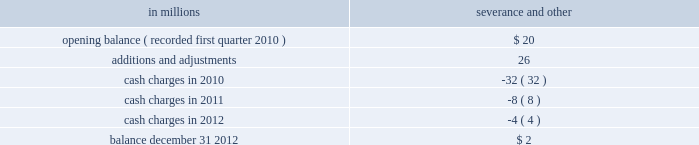The table presents a rollforward of the severance and other costs for approximately 1650 employees included in the 2010 restructuring charg- in millions severance and other .
As of december 31 , 2012 , 1638 employees had left the company under these programs .
Cellulosic bio-fuel tax credit in a memorandum dated june 28 , 2010 , the irs concluded that black liquor would qualify for the cellulosic bio-fuel tax credit of $ 1.01 per gallon pro- duced in 2009 .
On october 15 , 2010 , the irs ruled that companies may qualify in the same year for the $ 0.50 per gallon alternative fuel mixture credit and the $ 1.01 cellulosic bio-fuel tax credit for 2009 , but not for the same gallons of fuel produced and con- sumed .
To the extent a taxpayer changes its position and uses the $ 1.01 credit , it must re-pay the refunds they received as alternative fuel mixture credits attributable to the gallons converted to the cellulosic bio-fuel credit .
The repayment of this refund must include interest .
One important difference between the two credits is that the $ 1.01 credit must be credited against a company 2019s federal tax liability , and the credit may be carried forward through 2015 .
In contrast , the $ 0.50 credit is refundable in cash .
Also , the cellulosic bio- fuel credit is required to be included in federal tax- able income .
The company filed an application with the irs on november 18 , 2010 , to receive the required registra- tion code to become a registered cellulosic bio-fuel producer .
The company received its registration code on february 28 , 2011 .
The company has evaluated the optimal use of the two credits with respect to gallons produced in 2009 .
Considerations include uncertainty around future federal taxable income , the taxability of the alter- native fuel mixture credit , future liquidity and uses of cash such as , but not limited to , acquisitions , debt repayments and voluntary pension contributions versus repayment of alternative fuel mixture credits with interest .
At the present time , the company does not intend to convert any gallons under the alter- native fuel mixture credit to gallons under the cellulosic bio-fuel credit .
On july 19 , 2011 the com- pany filed an amended 2009 tax return claiming alternative fuel mixture tax credits as non-taxable income .
If that amended position is not upheld , the company will re-evaluate its position with regard to alternative fuel mixture gallons produced in 2009 .
During 2009 , the company produced 64 million gal- lons of black liquor that were not eligible for the alternative fuel mixture credit .
The company claimed these gallons for the cellulosic bio-fuel credit by amending the company 2019s 2009 tax return .
The impact of this amendment was included in the company 2019s 2010 fourth quarter income tax provision ( benefit ) , resulting in a $ 40 million net credit to tax expense .
Temple-inland , inc .
Also recognized an income tax benefit of $ 83 million in 2010 related to cellulosic bio-fuel credits .
As is the case with other tax credits , taxpayer claims are subject to possible future review by the irs which has the authority to propose adjustments to the amounts claimed , or credits received .
Note 5 acquisitions and joint ventures acquisitions 2013 : on january 3 , 2013 , international paper completed the acquisition ( effective date of acquis- ition on january 1 , 2013 ) of the shares of its joint venture partner , sabanci holding , in the turkish corrugated packaging company , olmuksa interna- tional paper sabanci ambalaj sanayi ve ticaret a.s .
( olmuksa ) , for a purchase price of $ 56 million .
The acquired shares represent 43.7% ( 43.7 % ) of olmuksa 2019s shares , and prior to this acquisition , international paper already held a 43.7% ( 43.7 % ) equity interest in olmuk- sa .
Thus , international paper now owns 87.4% ( 87.4 % ) of olmuksa 2019s outstanding and issued shares .
The company has not completed the valuation of assets acquired and liabilities assumed ; however , the company anticipates providing a preliminary pur- chase price allocation in its 2013 first quarter form 10-q filing .
Because the transaction resulted in international paper becoming the majority shareholder , owning 87.4% ( 87.4 % ) of olmuksa 2019s shares , its completion triggered a mandatory call for tender of the remaining public shares .
Also as a result of international paper taking majority control of the entity , olmuksa 2019s financial results will be consolidated with our industrial pack- aging segment beginning with the effective date international paper obtained majority control of the entity on january 1 , 2013 .
Pro forma information related to the acquisition of olmuksa has not been included as it does not have a material effect on the company 2019s consolidated results of operations .
2012 : on february 13 , 2012 , international paper com- pleted the acquisition of temple-inland , inc .
( temple- inland ) .
International paper acquired all of the outstanding common stock of temple-inland for $ 32.00 per share in cash , totaling approximately $ 3.7 billion .
Based on the review of the table what was the net change in the restructuring charg- in millions severance and other in millions? 
Computations: (2 - 20)
Answer: -18.0. 